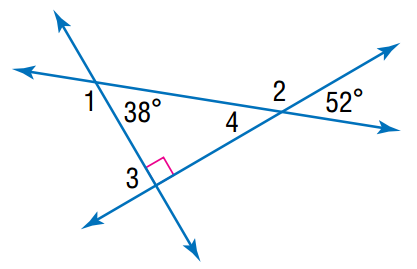Question: Find the angle measure of \angle 4.
Choices:
A. 38
B. 42
C. 52
D. 62
Answer with the letter. Answer: C Question: Find the angle measure of \angle 2.
Choices:
A. 128
B. 138
C. 142
D. 148
Answer with the letter. Answer: A Question: Find the angle measure of \angle 3.
Choices:
A. 38
B. 52
C. 90
D. 180
Answer with the letter. Answer: C Question: Find the angle measure of \angle 1.
Choices:
A. 128
B. 132
C. 142
D. 152
Answer with the letter. Answer: C 